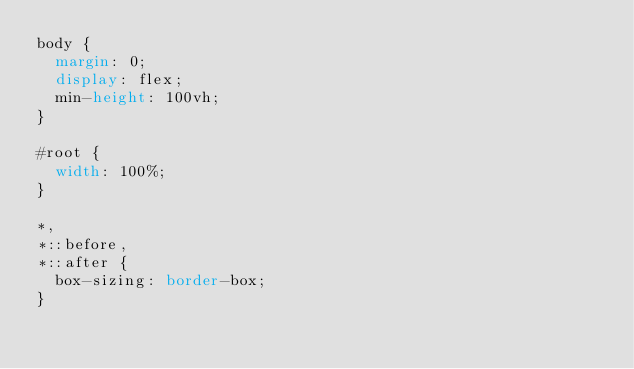Convert code to text. <code><loc_0><loc_0><loc_500><loc_500><_CSS_>body {
  margin: 0;
  display: flex;
  min-height: 100vh;
}

#root {
  width: 100%;
}

*,
*::before,
*::after {
  box-sizing: border-box;
}
</code> 